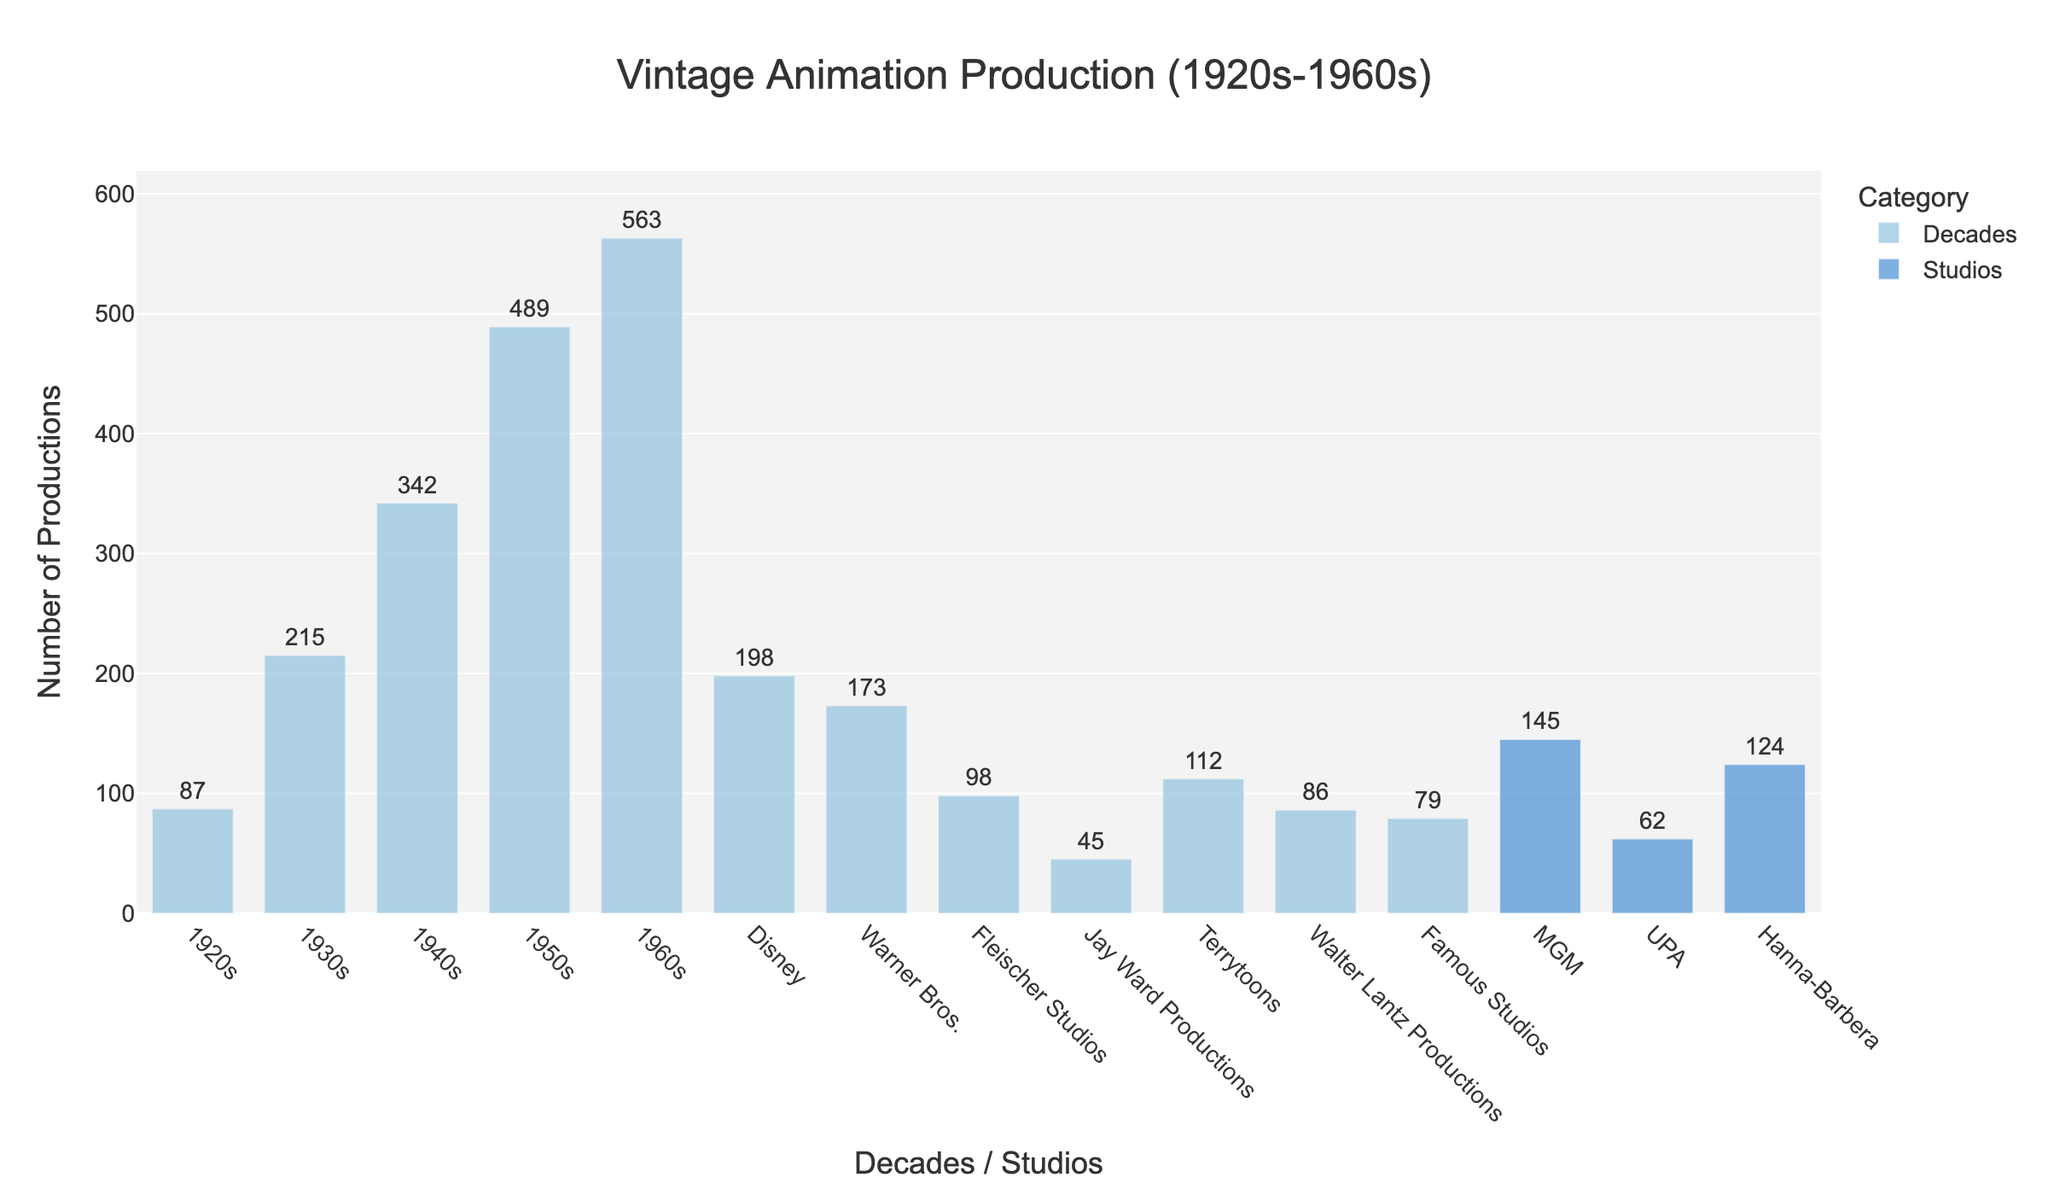what's the total number of productions in the 1930s and 1940s combined? To find the total number of productions in the two decades, add the numbers from each decade: 215 (1930s) + 342 (1940s) = 557
Answer: 557 which decade had the highest number of productions? Observe the heights of the bars representing each decade. The bar for the 1960s is the tallest, indicating the highest number of productions at 563
Answer: 1960s how many more productions were there in the 1950s compared to the 1920s? Subtract the number of productions in the 1920s from those in the 1950s: 489 (1950s) - 87 (1920s) = 402
Answer: 402 which studio had the lowest number of productions among those listed? Observe the heights of the bars representing each studio. Jay Ward Productions has the shortest bar with 45 productions
Answer: Jay Ward Productions how many productions in total were there from Disney and Warner Bros. combined? To find the total productions from the two studios, add the numbers from each: 198 (Disney) + 173 (Warner Bros.) = 371
Answer: 371 compare the number of productions by Fleischer Studios and Hanna-Barbera. Which one had more, and by how much? Observe the heights of the bars representing each studio. Hanna-Barbera had 124 productions, while Fleischer Studios had 98. Subtract Fleischer Studios' number from Hanna-Barbera's: 124 - 98 = 26
Answer: Hanna-Barbera by 26 what is the combined number of productions in the 1950s and 1960s? Add the count of productions for these two decades: 489 (1950s) + 563 (1960s) = 1052
Answer: 1052 how many production companies listed have over 100 productions? Count the number of studios with bars representing over 100 productions. They are Disney, Warner Bros., MGM, Hanna-Barbera, and Terrytoons, totaling 5 studios
Answer: 5 which decade saw a significant increase in production compared to the previous decade? Compare the differences in production between consecutive decades. The change from the 1940s (342 productions) to the 1950s (489 productions) shows a significant increase of 147 productions
Answer: 1950s what's the average number of productions per decade from the 1920s to the 1960s? Add the total number of productions and divide by the number of decades: (87 + 215 + 342 + 489 + 563) / 5 = 1696 / 5 = 339.2
Answer: 339.2 